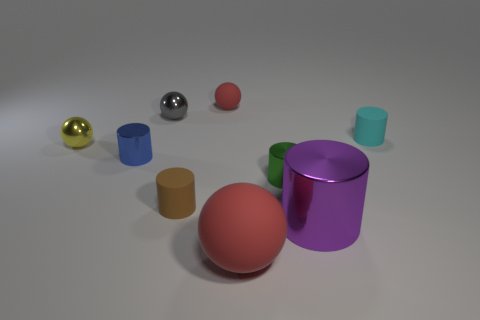What color is the matte cylinder that is to the left of the red matte thing to the right of the red thing that is to the left of the large matte object?
Provide a succinct answer. Brown. What number of metallic things are blue cubes or cyan objects?
Ensure brevity in your answer.  0. Is the number of small red matte objects that are behind the large red sphere greater than the number of tiny gray metallic objects on the left side of the big purple shiny cylinder?
Keep it short and to the point. No. What number of other things are the same size as the cyan thing?
Your answer should be very brief. 6. There is a red rubber object that is behind the cylinder on the left side of the small gray shiny object; what is its size?
Give a very brief answer. Small. How many small things are either green shiny objects or cylinders?
Your answer should be very brief. 4. How big is the red thing that is in front of the matte cylinder behind the small ball that is in front of the gray ball?
Your response must be concise. Large. Are there any other things that have the same color as the big shiny object?
Offer a very short reply. No. What is the red ball that is in front of the matte object that is right of the sphere on the right side of the small red matte thing made of?
Your answer should be very brief. Rubber. Is the shape of the blue thing the same as the small brown rubber object?
Offer a terse response. Yes. 